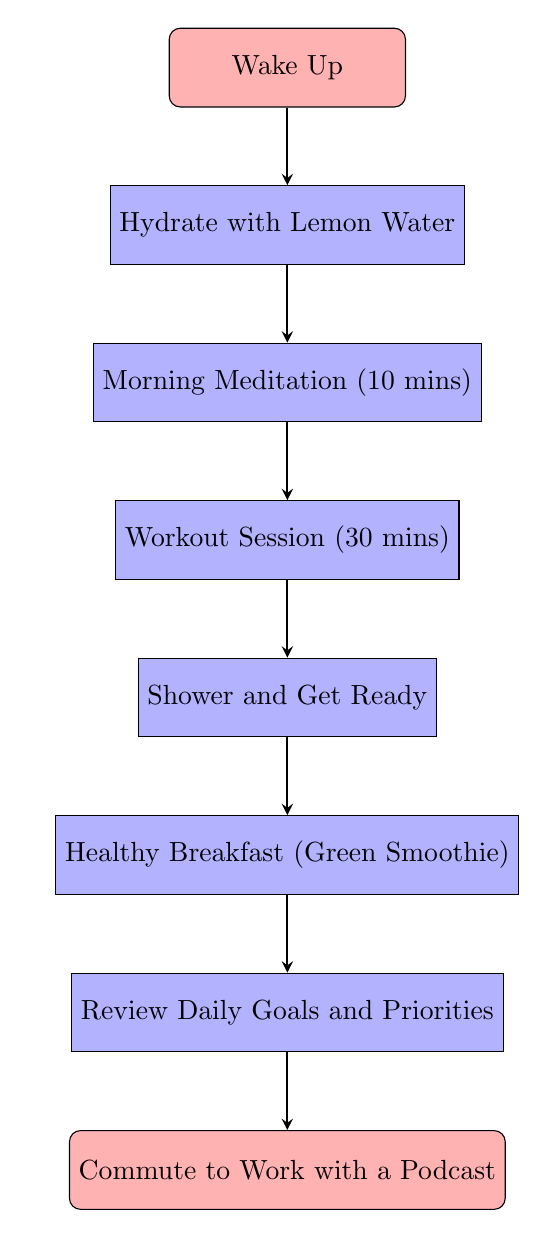What is the first step in the morning routine? The first step in the morning routine is indicated at the top of the flowchart, labeled as "Wake Up."
Answer: Wake Up How many total steps are in the morning routine? By counting each node in the diagram, we find there are 8 steps from "Wake Up" to "Commute to Work with a Podcast."
Answer: 8 What follows the workout session? The node directly below "Workout Session (30 mins)" is "Shower and Get Ready," indicating the next step in the routine.
Answer: Shower and Get Ready What is the last activity before commuting to work? The last activity listed before the "Commute to Work with a Podcast" is "Review Daily Goals and Priorities," which tells us it is the final preparation step.
Answer: Review Daily Goals and Priorities Which activity does not involve physical exertion? Looking through the diagram, "Review Daily Goals and Priorities" is the only activity that does not involve physical exertion, as it is a cognitive task.
Answer: Review Daily Goals and Priorities After hydrating, what type of activity follows? After the hydration step "Hydrate with Lemon Water," the next activity is "Morning Meditation (10 mins)," which is a calm and focused activity following hydration.
Answer: Morning Meditation (10 mins) Is there any food-related activity early in the routine? The first food-related activity within the routine occurs toward the end, specifically at "Healthy Breakfast (Green Smoothie)," which is the only food-related step.
Answer: Healthy Breakfast (Green Smoothie) What is the purpose of commuting while listening to a podcast? The purpose of commuting to work with a podcast is implied to enhance the use of time during travel, likely by providing entertainment or education while transitioning to the work environment.
Answer: Enhancing use of time 